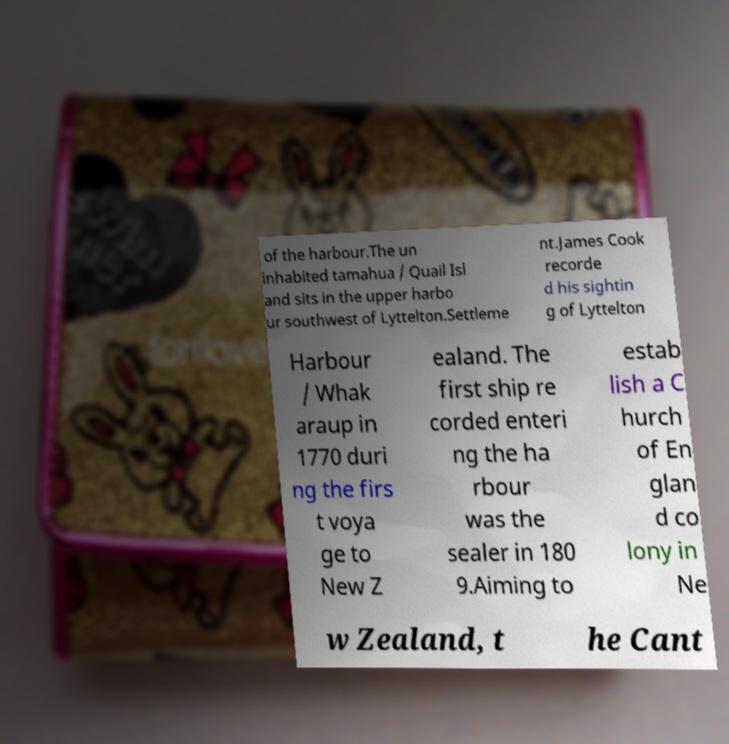Please read and relay the text visible in this image. What does it say? of the harbour.The un inhabited tamahua / Quail Isl and sits in the upper harbo ur southwest of Lyttelton.Settleme nt.James Cook recorde d his sightin g of Lyttelton Harbour / Whak araup in 1770 duri ng the firs t voya ge to New Z ealand. The first ship re corded enteri ng the ha rbour was the sealer in 180 9.Aiming to estab lish a C hurch of En glan d co lony in Ne w Zealand, t he Cant 